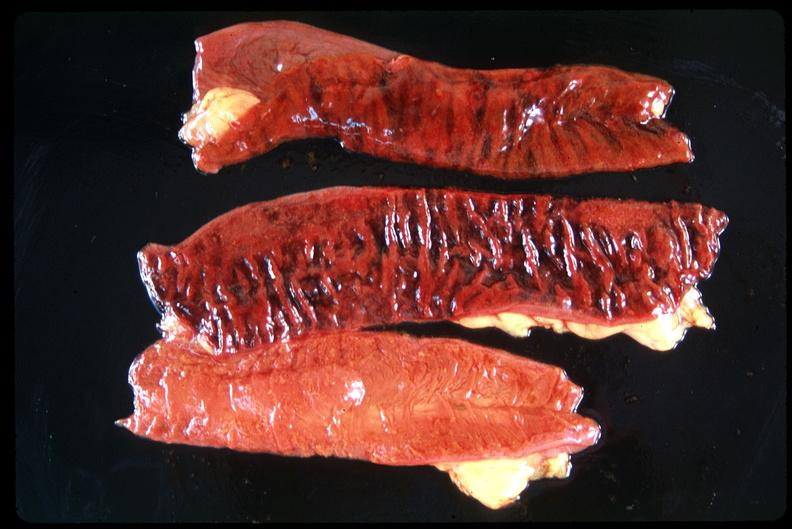does this image show small intestine, ischemic bowel?
Answer the question using a single word or phrase. Yes 